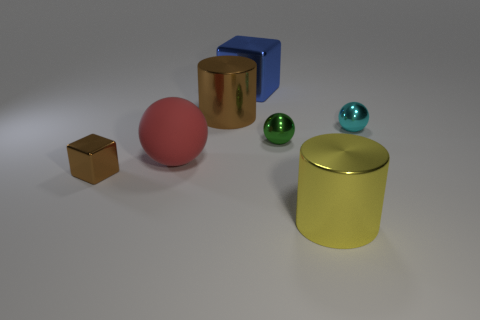Subtract all purple cylinders. Subtract all brown spheres. How many cylinders are left? 2 Add 2 large yellow rubber blocks. How many objects exist? 9 Subtract all spheres. How many objects are left? 4 Subtract all tiny brown metal cubes. Subtract all large rubber balls. How many objects are left? 5 Add 6 small brown things. How many small brown things are left? 7 Add 7 gray shiny objects. How many gray shiny objects exist? 7 Subtract 0 yellow cubes. How many objects are left? 7 